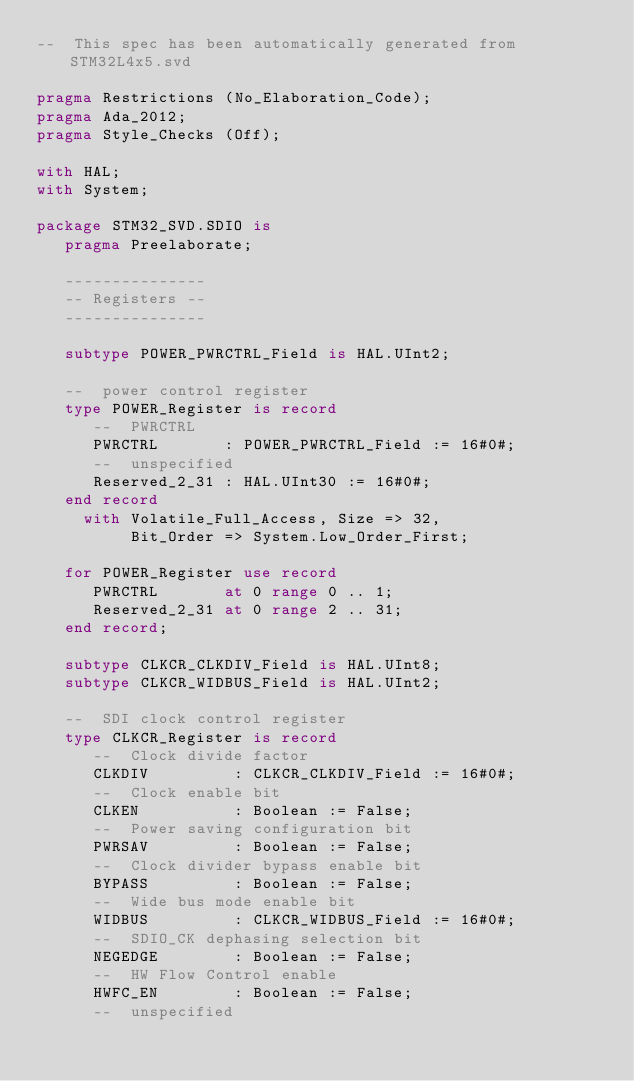Convert code to text. <code><loc_0><loc_0><loc_500><loc_500><_Ada_>--  This spec has been automatically generated from STM32L4x5.svd

pragma Restrictions (No_Elaboration_Code);
pragma Ada_2012;
pragma Style_Checks (Off);

with HAL;
with System;

package STM32_SVD.SDIO is
   pragma Preelaborate;

   ---------------
   -- Registers --
   ---------------

   subtype POWER_PWRCTRL_Field is HAL.UInt2;

   --  power control register
   type POWER_Register is record
      --  PWRCTRL
      PWRCTRL       : POWER_PWRCTRL_Field := 16#0#;
      --  unspecified
      Reserved_2_31 : HAL.UInt30 := 16#0#;
   end record
     with Volatile_Full_Access, Size => 32,
          Bit_Order => System.Low_Order_First;

   for POWER_Register use record
      PWRCTRL       at 0 range 0 .. 1;
      Reserved_2_31 at 0 range 2 .. 31;
   end record;

   subtype CLKCR_CLKDIV_Field is HAL.UInt8;
   subtype CLKCR_WIDBUS_Field is HAL.UInt2;

   --  SDI clock control register
   type CLKCR_Register is record
      --  Clock divide factor
      CLKDIV         : CLKCR_CLKDIV_Field := 16#0#;
      --  Clock enable bit
      CLKEN          : Boolean := False;
      --  Power saving configuration bit
      PWRSAV         : Boolean := False;
      --  Clock divider bypass enable bit
      BYPASS         : Boolean := False;
      --  Wide bus mode enable bit
      WIDBUS         : CLKCR_WIDBUS_Field := 16#0#;
      --  SDIO_CK dephasing selection bit
      NEGEDGE        : Boolean := False;
      --  HW Flow Control enable
      HWFC_EN        : Boolean := False;
      --  unspecified</code> 